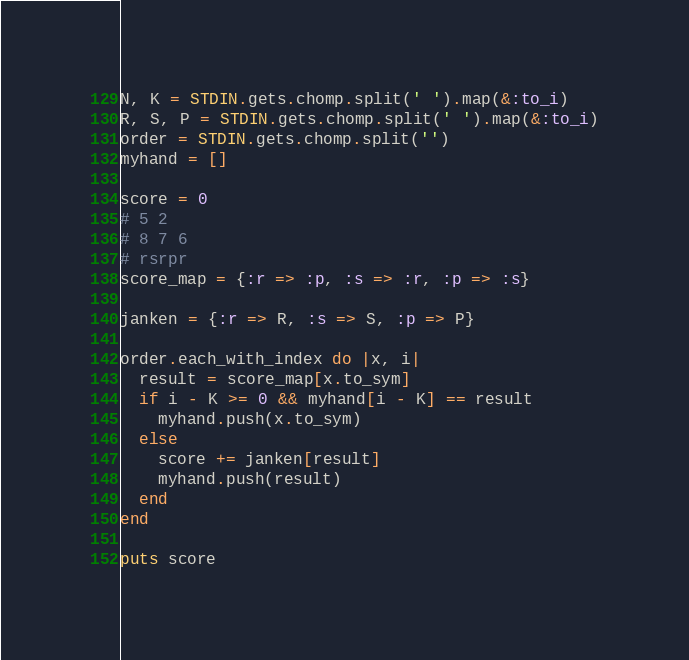<code> <loc_0><loc_0><loc_500><loc_500><_Ruby_>N, K = STDIN.gets.chomp.split(' ').map(&:to_i)
R, S, P = STDIN.gets.chomp.split(' ').map(&:to_i)
order = STDIN.gets.chomp.split('')
myhand = []

score = 0
# 5 2
# 8 7 6
# rsrpr
score_map = {:r => :p, :s => :r, :p => :s}

janken = {:r => R, :s => S, :p => P}

order.each_with_index do |x, i|
  result = score_map[x.to_sym]
  if i - K >= 0 && myhand[i - K] == result
    myhand.push(x.to_sym)
  else
    score += janken[result]
    myhand.push(result)
  end
end

puts score

</code> 